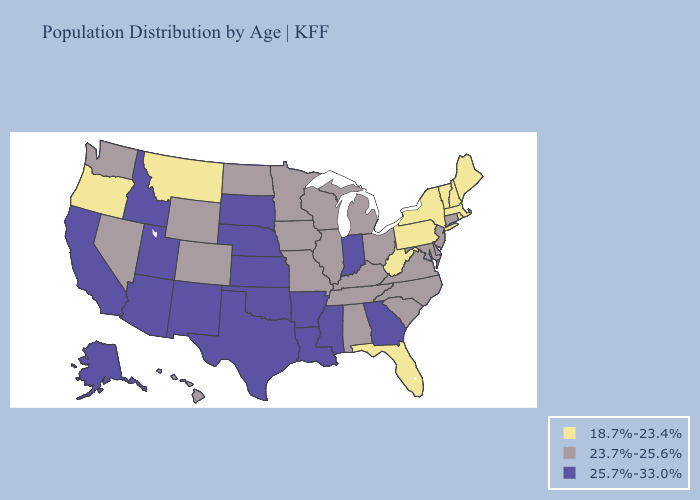What is the value of California?
Quick response, please. 25.7%-33.0%. Does Tennessee have a higher value than Pennsylvania?
Give a very brief answer. Yes. Name the states that have a value in the range 25.7%-33.0%?
Keep it brief. Alaska, Arizona, Arkansas, California, Georgia, Idaho, Indiana, Kansas, Louisiana, Mississippi, Nebraska, New Mexico, Oklahoma, South Dakota, Texas, Utah. What is the value of Nevada?
Short answer required. 23.7%-25.6%. Which states have the lowest value in the Northeast?
Write a very short answer. Maine, Massachusetts, New Hampshire, New York, Pennsylvania, Rhode Island, Vermont. Name the states that have a value in the range 23.7%-25.6%?
Keep it brief. Alabama, Colorado, Connecticut, Delaware, Hawaii, Illinois, Iowa, Kentucky, Maryland, Michigan, Minnesota, Missouri, Nevada, New Jersey, North Carolina, North Dakota, Ohio, South Carolina, Tennessee, Virginia, Washington, Wisconsin, Wyoming. How many symbols are there in the legend?
Give a very brief answer. 3. Does the first symbol in the legend represent the smallest category?
Give a very brief answer. Yes. What is the value of Rhode Island?
Write a very short answer. 18.7%-23.4%. What is the value of North Dakota?
Be succinct. 23.7%-25.6%. Name the states that have a value in the range 23.7%-25.6%?
Short answer required. Alabama, Colorado, Connecticut, Delaware, Hawaii, Illinois, Iowa, Kentucky, Maryland, Michigan, Minnesota, Missouri, Nevada, New Jersey, North Carolina, North Dakota, Ohio, South Carolina, Tennessee, Virginia, Washington, Wisconsin, Wyoming. What is the highest value in states that border Nevada?
Write a very short answer. 25.7%-33.0%. Does Missouri have the lowest value in the USA?
Keep it brief. No. Does the map have missing data?
Answer briefly. No. Does Nebraska have the highest value in the MidWest?
Quick response, please. Yes. 